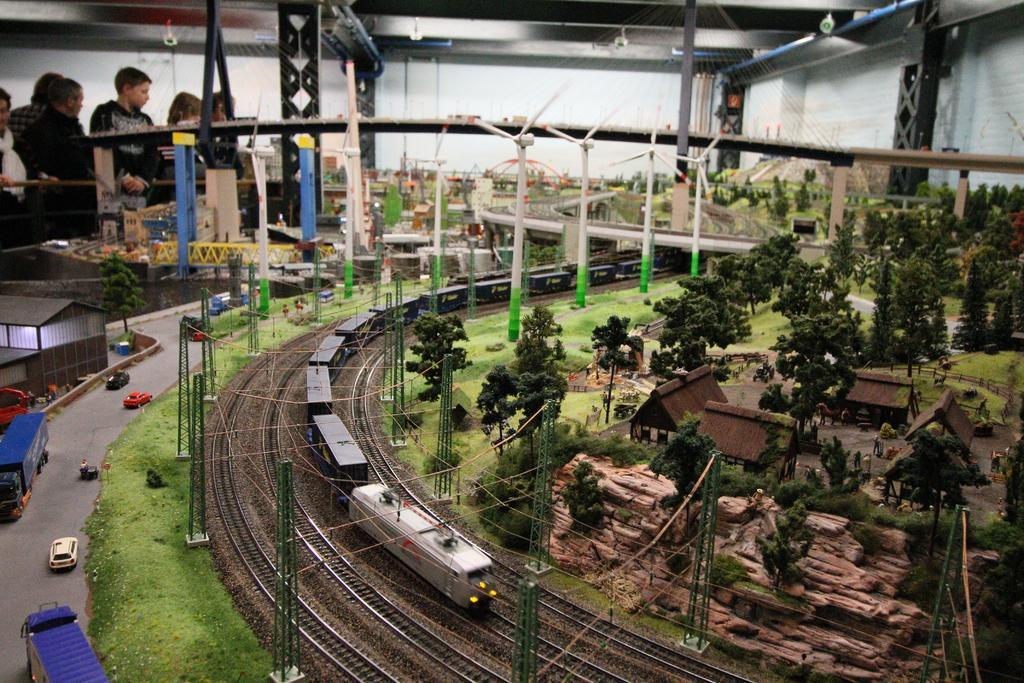Can you describe this image briefly? In this picture there is a train on the track and there are few other tracks beside it and there are few trees,houses,bridge and some other objects in the right corner and there are few toy vehicles and few people standing in the left corner. 